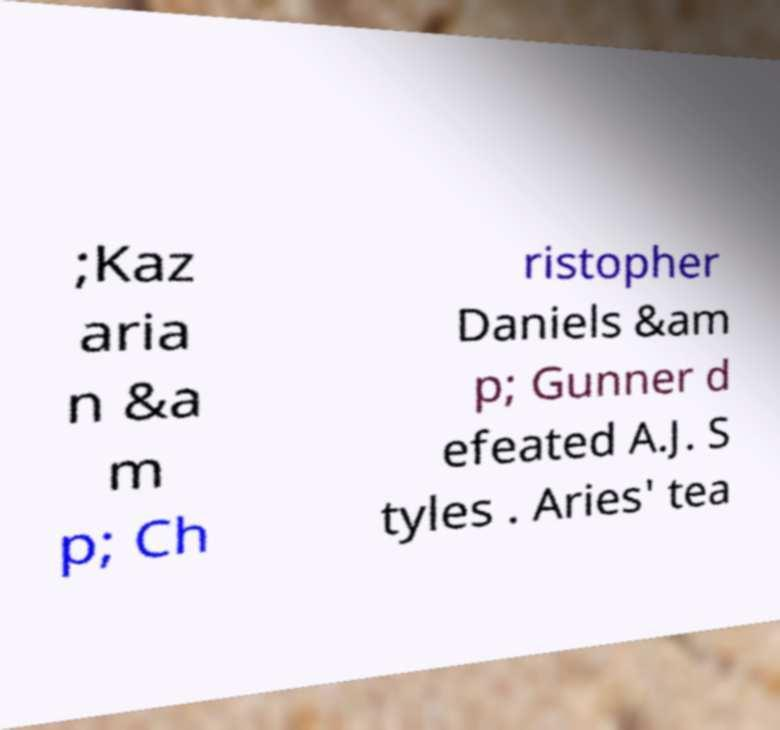What messages or text are displayed in this image? I need them in a readable, typed format. ;Kaz aria n &a m p; Ch ristopher Daniels &am p; Gunner d efeated A.J. S tyles . Aries' tea 